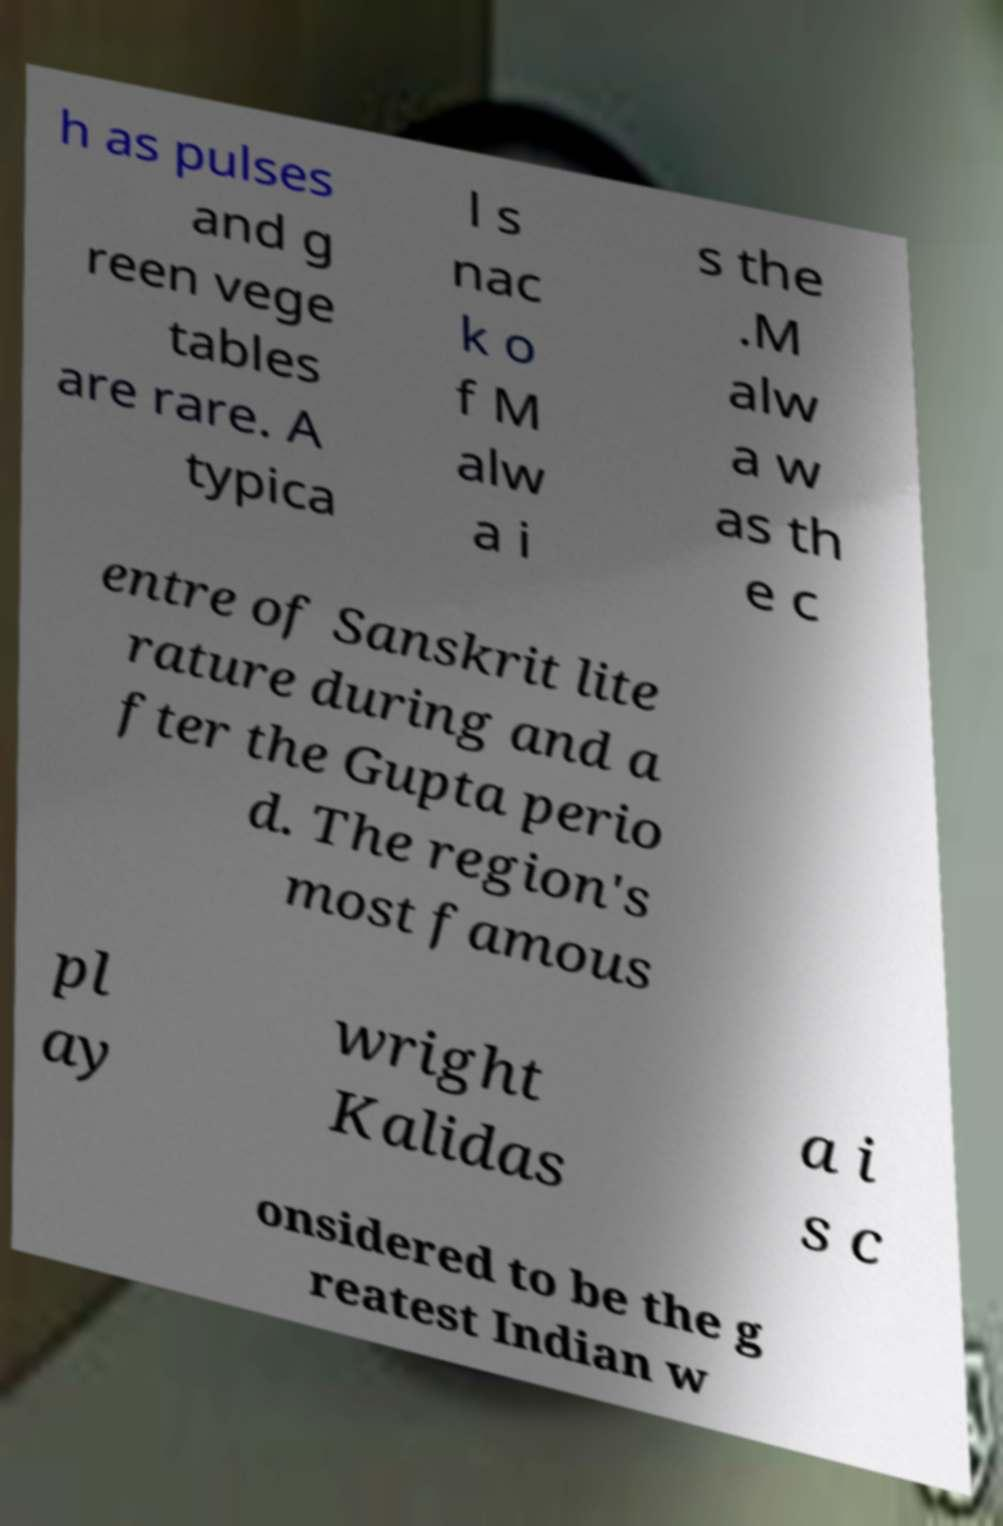Can you accurately transcribe the text from the provided image for me? h as pulses and g reen vege tables are rare. A typica l s nac k o f M alw a i s the .M alw a w as th e c entre of Sanskrit lite rature during and a fter the Gupta perio d. The region's most famous pl ay wright Kalidas a i s c onsidered to be the g reatest Indian w 